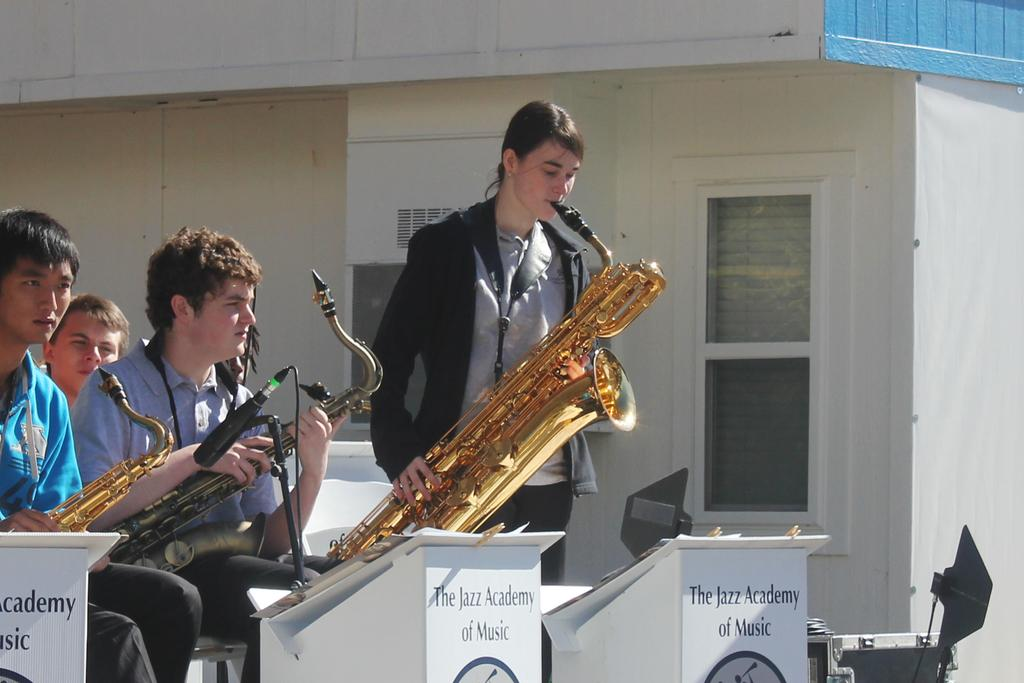<image>
Present a compact description of the photo's key features. Young men playing instruments in front of music stands that say The Jazz Academy of Music on them. 